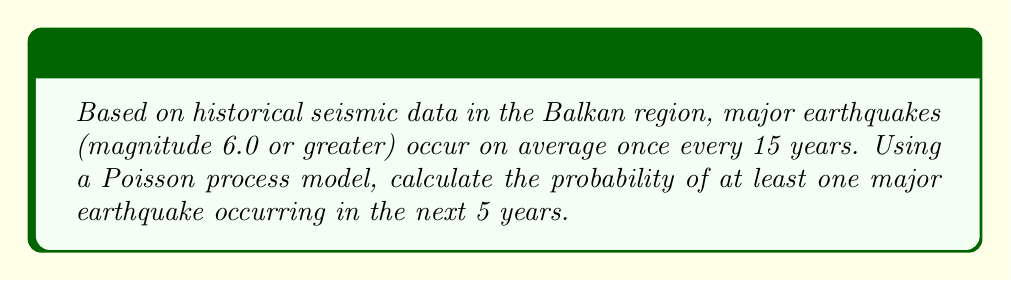Can you solve this math problem? To solve this problem, we'll use the Poisson process model, which is suitable for rare events occurring over time. Let's follow these steps:

1. Identify the given information:
   - Average rate (λ) = 1 event per 15 years
   - Time period (t) = 5 years
   - We need to find P(X ≥ 1), where X is the number of events

2. Calculate the rate for the given time period:
   λt = (1/15) * 5 = 1/3

3. The probability of exactly k events in time t is given by the Poisson probability mass function:
   $$P(X = k) = \frac{e^{-λt}(λt)^k}{k!}$$

4. We need P(X ≥ 1), which is equivalent to 1 - P(X = 0):
   P(X ≥ 1) = 1 - P(X = 0)

5. Calculate P(X = 0):
   $$P(X = 0) = \frac{e^{-1/3}(1/3)^0}{0!} = e^{-1/3}$$

6. Calculate the final probability:
   P(X ≥ 1) = 1 - $e^{-1/3}$ ≈ 0.2835

Therefore, the probability of at least one major earthquake occurring in the next 5 years is approximately 0.2835 or 28.35%.
Answer: 0.2835 